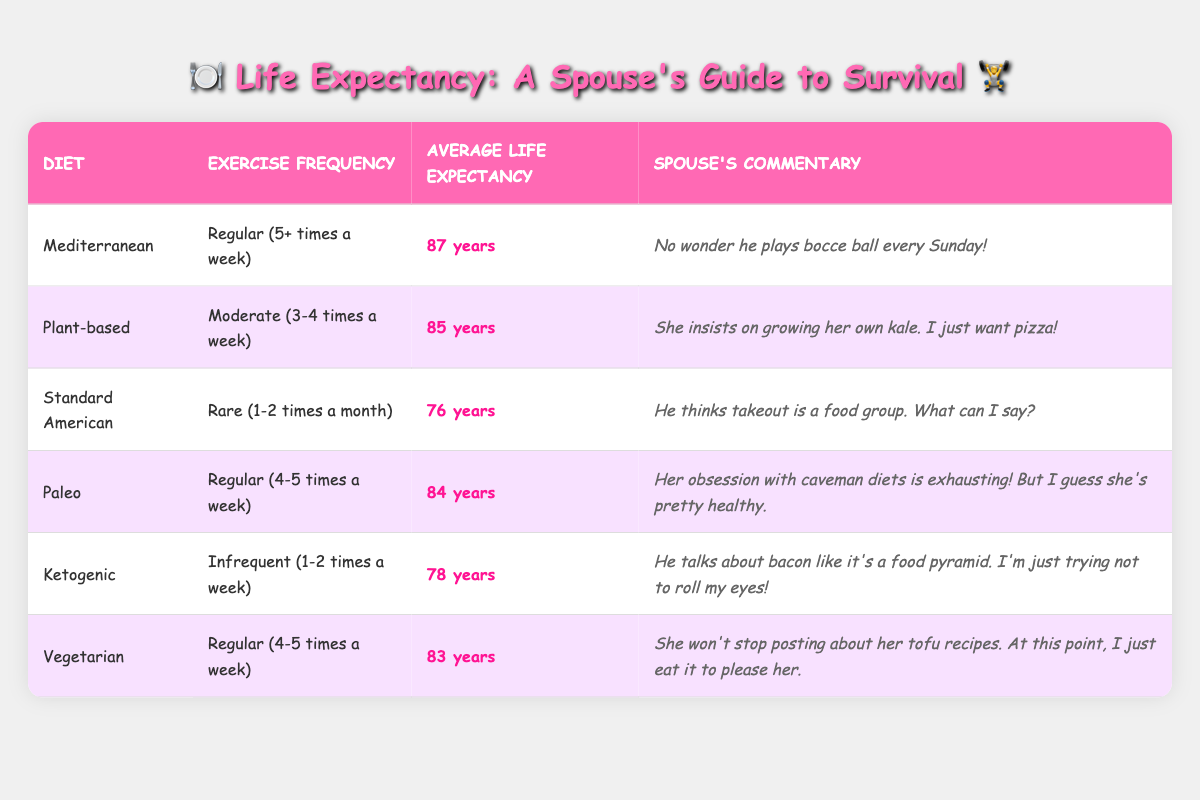What's the average life expectancy for those with a Mediterranean diet and regular exercise? The table states that the average life expectancy for the Mediterranean diet is 87 years. Since the exercise frequency is regular, we can use this value directly without any calculations.
Answer: 87 years What diet has the lowest average life expectancy? Looking at the table, the Standard American diet has the lowest average life expectancy at 76 years.
Answer: Standard American Is it true that individuals following a ketogenic diet have a higher average life expectancy than those on a Standard American diet? Comparing the average life expectancies, the ketogenic diet has an average of 78 years, while the Standard American diet is at 76 years. Since 78 is greater than 76, the statement is true.
Answer: Yes What is the life expectancy difference between those following a Mediterranean diet and a plant-based diet? The Mediterranean diet has an average life expectancy of 87 years, while the plant-based diet has 85 years. The difference is calculated as 87 - 85 = 2 years.
Answer: 2 years Which exercise frequency category corresponds to the paleo diet? The table indicates that the paleo diet has a regular exercise frequency, noted as 4-5 times a week.
Answer: Regular (4-5 times a week) Do both the vegetarian and Mediterranean diets provide the same average life expectancy? The vegetarian diet has an average life expectancy of 83 years and the Mediterranean diet has 87 years. Since they are different, the statement is false.
Answer: No How many diet categories have an average life expectancy of over 80 years? Referring to the table, the Mediterranean (87), plant-based (85), paleo (84), and vegetarian (83) diets all have life expectancies over 80 years, totaling 4 categories.
Answer: 4 categories If an individual chooses a plant-based diet, what total life expectancy would they have compared to someone on a ketogenic diet? The average life expectancy for a plant-based diet is 85 years and for a ketogenic diet is 78 years. The total when adding these two values is 85 + 78 = 163 years.
Answer: 163 years In terms of average life expectancy, what does the data suggest about the relationship between exercise frequency and diet? Analyzing the table shows that diets paired with higher exercise frequencies, such as Mediterranean and vegetarian, tend to have higher life expectancies (87 and 83 years). Meanwhile, the Standard American diet, with rare exercise, has a lower expectancy (76 years). This suggests a positive correlation between exercise frequency and life expectancy.
Answer: Positive correlation 